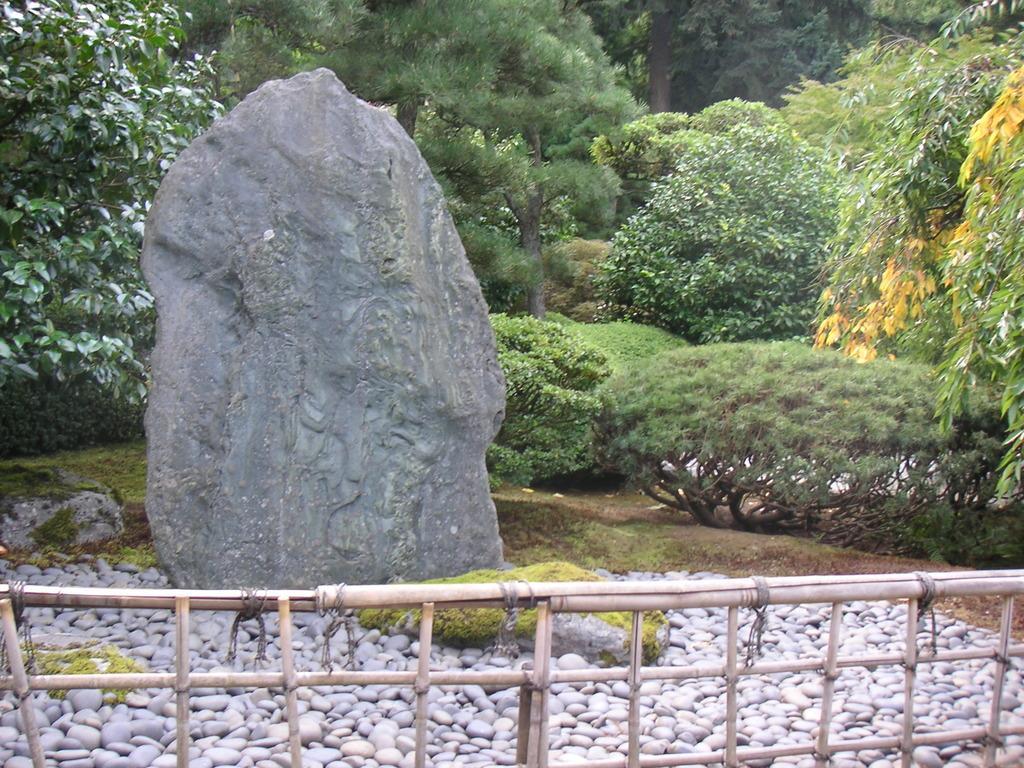Please provide a concise description of this image. In the picture I can see a rock and there are few small rocks and a fence in front of it and there are trees in the background. 